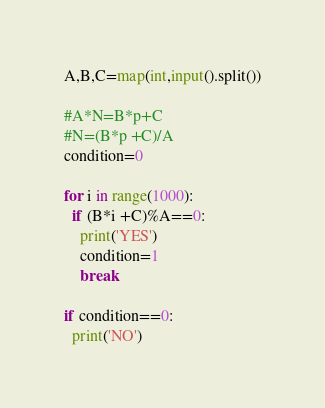Convert code to text. <code><loc_0><loc_0><loc_500><loc_500><_Python_>A,B,C=map(int,input().split())

#A*N=B*p+C
#N=(B*p +C)/A
condition=0

for i in range(1000):
  if (B*i +C)%A==0:
    print('YES')
    condition=1
    break
 
if condition==0:
  print('NO')</code> 